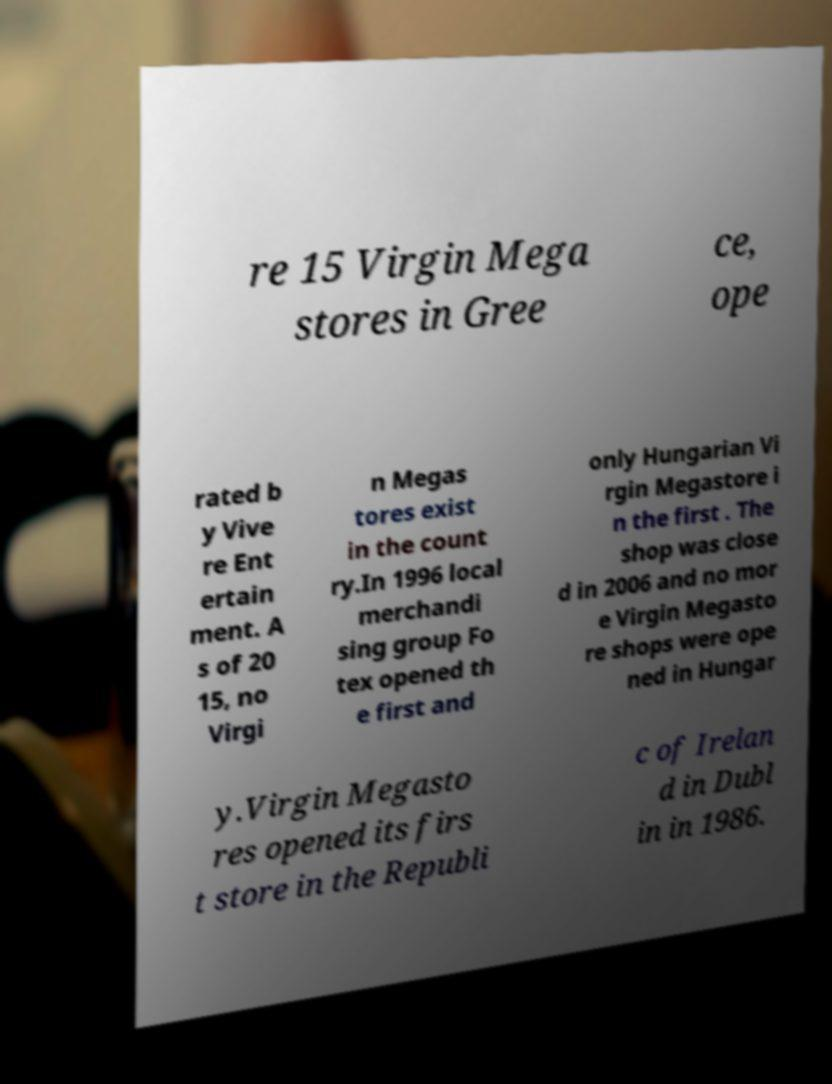Could you extract and type out the text from this image? re 15 Virgin Mega stores in Gree ce, ope rated b y Vive re Ent ertain ment. A s of 20 15, no Virgi n Megas tores exist in the count ry.In 1996 local merchandi sing group Fo tex opened th e first and only Hungarian Vi rgin Megastore i n the first . The shop was close d in 2006 and no mor e Virgin Megasto re shops were ope ned in Hungar y.Virgin Megasto res opened its firs t store in the Republi c of Irelan d in Dubl in in 1986. 